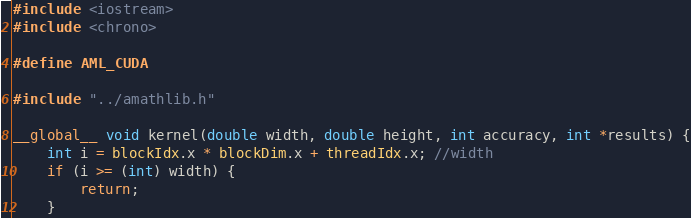Convert code to text. <code><loc_0><loc_0><loc_500><loc_500><_Cuda_>
#include <iostream>
#include <chrono>

#define AML_CUDA

#include "../amathlib.h"

__global__ void kernel(double width, double height, int accuracy, int *results) {
	int i = blockIdx.x * blockDim.x + threadIdx.x; //width
	if (i >= (int) width) {
		return;
	}</code> 